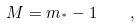<formula> <loc_0><loc_0><loc_500><loc_500>M = m _ { ^ { * } } - 1 \quad ,</formula> 